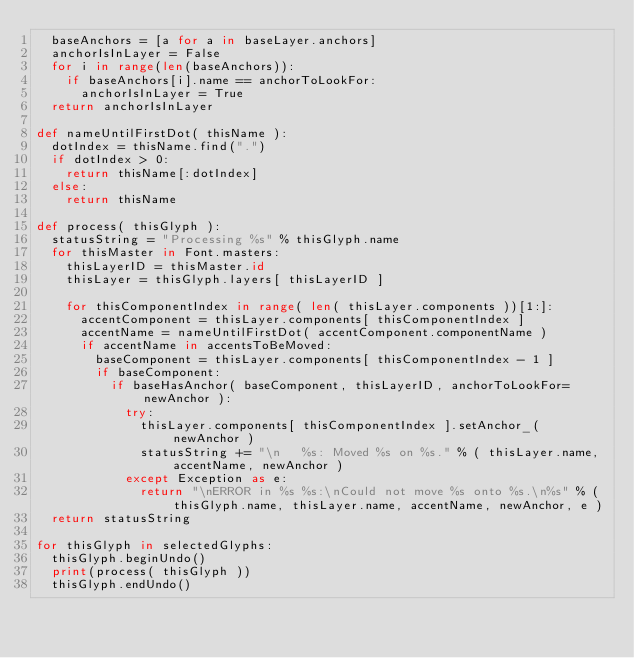Convert code to text. <code><loc_0><loc_0><loc_500><loc_500><_Python_>	baseAnchors = [a for a in baseLayer.anchors]
	anchorIsInLayer = False
	for i in range(len(baseAnchors)):
		if baseAnchors[i].name == anchorToLookFor:
			anchorIsInLayer = True
	return anchorIsInLayer

def nameUntilFirstDot( thisName ):
	dotIndex = thisName.find(".")
	if dotIndex > 0:
		return thisName[:dotIndex]
	else:
		return thisName

def process( thisGlyph ):
	statusString = "Processing %s" % thisGlyph.name
	for thisMaster in Font.masters:
		thisLayerID = thisMaster.id
		thisLayer = thisGlyph.layers[ thisLayerID ]
		
		for thisComponentIndex in range( len( thisLayer.components ))[1:]:
			accentComponent = thisLayer.components[ thisComponentIndex ]
			accentName = nameUntilFirstDot( accentComponent.componentName )
			if accentName in accentsToBeMoved:
				baseComponent = thisLayer.components[ thisComponentIndex - 1 ]
				if baseComponent:
					if baseHasAnchor( baseComponent, thisLayerID, anchorToLookFor=newAnchor ):
						try:
							thisLayer.components[ thisComponentIndex ].setAnchor_( newAnchor )
							statusString += "\n   %s: Moved %s on %s." % ( thisLayer.name, accentName, newAnchor )
						except Exception as e:
							return "\nERROR in %s %s:\nCould not move %s onto %s.\n%s" % ( thisGlyph.name, thisLayer.name, accentName, newAnchor, e )
	return statusString

for thisGlyph in selectedGlyphs:
	thisGlyph.beginUndo()
	print(process( thisGlyph ))
	thisGlyph.endUndo()

</code> 